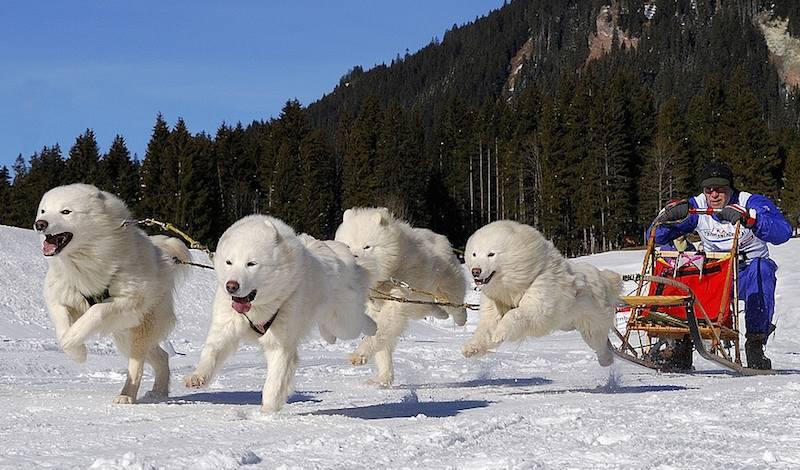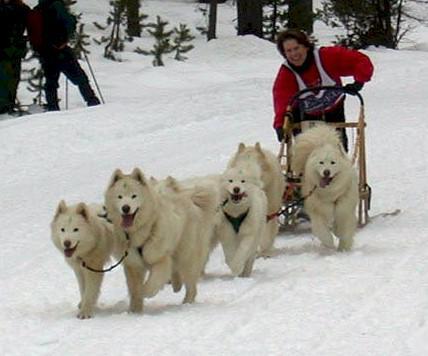The first image is the image on the left, the second image is the image on the right. For the images displayed, is the sentence "There is a man wearing red outerwear on a sled." factually correct? Answer yes or no. Yes. 